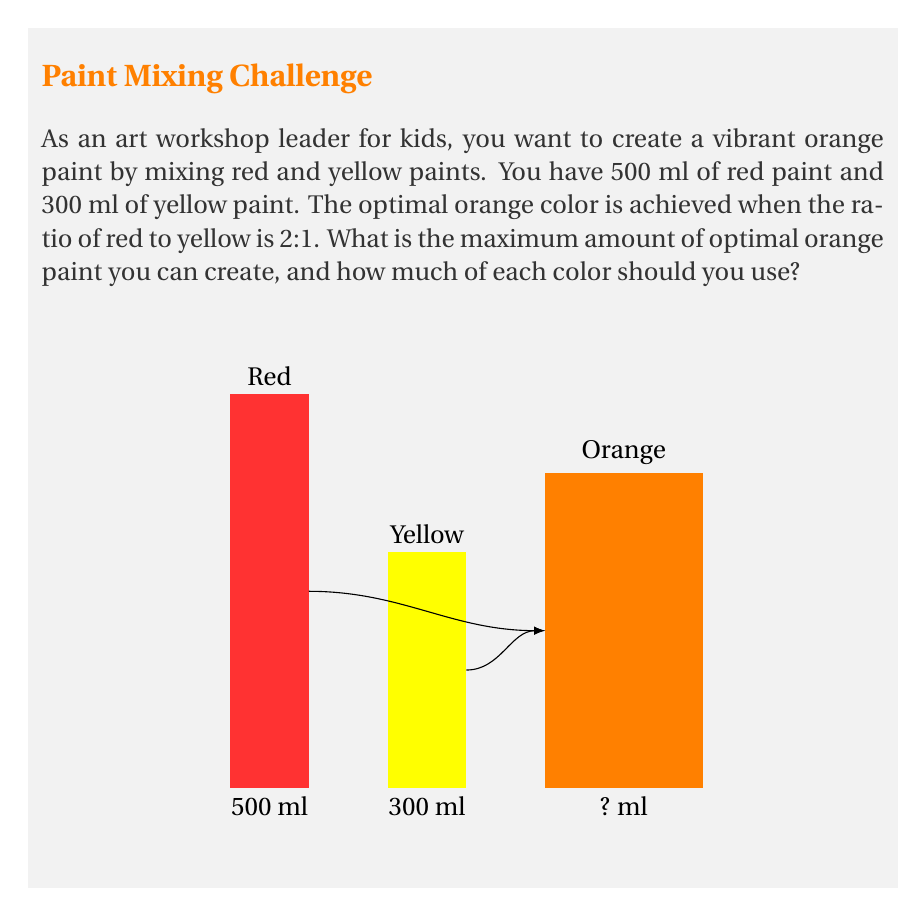Could you help me with this problem? Let's approach this step-by-step:

1) Let $x$ be the amount of red paint used and $y$ be the amount of yellow paint used.

2) The constraints are:
   $x \leq 500$ (available red paint)
   $y \leq 300$ (available yellow paint)

3) The optimal ratio is 2:1 (red:yellow), so we can express this as:
   $\frac{x}{y} = \frac{2}{1}$ or $x = 2y$

4) The total amount of orange paint created will be $x + y$.

5) We want to maximize $x + y$ subject to our constraints.

6) Substituting $x = 2y$ into our constraints:
   $2y \leq 500$ and $y \leq 300$

7) From $2y \leq 500$, we get $y \leq 250$. 
   The limiting factor is $y \leq 250$ (from the red paint constraint) rather than $y \leq 300$.

8) Therefore, the maximum value for $y$ is 250 ml.

9) If $y = 250$, then $x = 2y = 500$ ml.

10) The total amount of orange paint created is:
    $x + y = 500 + 250 = 750$ ml

Therefore, you should use 500 ml of red paint and 250 ml of yellow paint to create 750 ml of optimal orange paint.
Answer: 750 ml of orange paint; 500 ml red, 250 ml yellow 